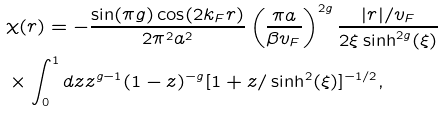<formula> <loc_0><loc_0><loc_500><loc_500>& \chi ( r ) = - \frac { \sin ( \pi g ) \cos ( 2 k _ { F } r ) } { 2 \pi ^ { 2 } a ^ { 2 } } \left ( \frac { \pi a } { \beta v _ { F } } \right ) ^ { 2 g } \frac { | r | / v _ { F } } { 2 \xi \sinh ^ { 2 g } ( \xi ) } \\ & \times \int _ { 0 } ^ { 1 } d z z ^ { g - 1 } ( 1 - z ) ^ { - g } [ 1 + z / \sinh ^ { 2 } ( \xi ) ] ^ { - 1 / 2 } ,</formula> 